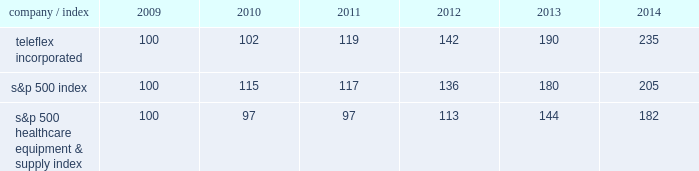Stock performance graph the following graph provides a comparison of five year cumulative total stockholder returns of teleflex common stock , the standard & poor 2019s ( s&p ) 500 stock index and the s&p 500 healthcare equipment & supply index .
The annual changes for the five-year period shown on the graph are based on the assumption that $ 100 had been invested in teleflex common stock and each index on december 31 , 2009 and that all dividends were reinvested .
Market performance .
S&p 500 healthcare equipment & supply index 100 97 97 113 144 182 .
What is the range of market performance for the two indexes in 2014? 
Computations: (235 - 182)
Answer: 53.0. 